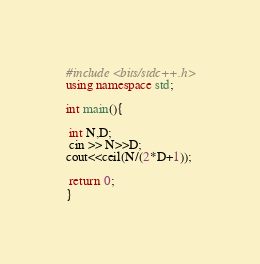Convert code to text. <code><loc_0><loc_0><loc_500><loc_500><_C++_>#include <bits/stdc++.h>
using namespace std;

int main(){

 int N,D;
 cin >> N>>D;
cout<<ceil(N/(2*D+1));

 return 0;
}</code> 